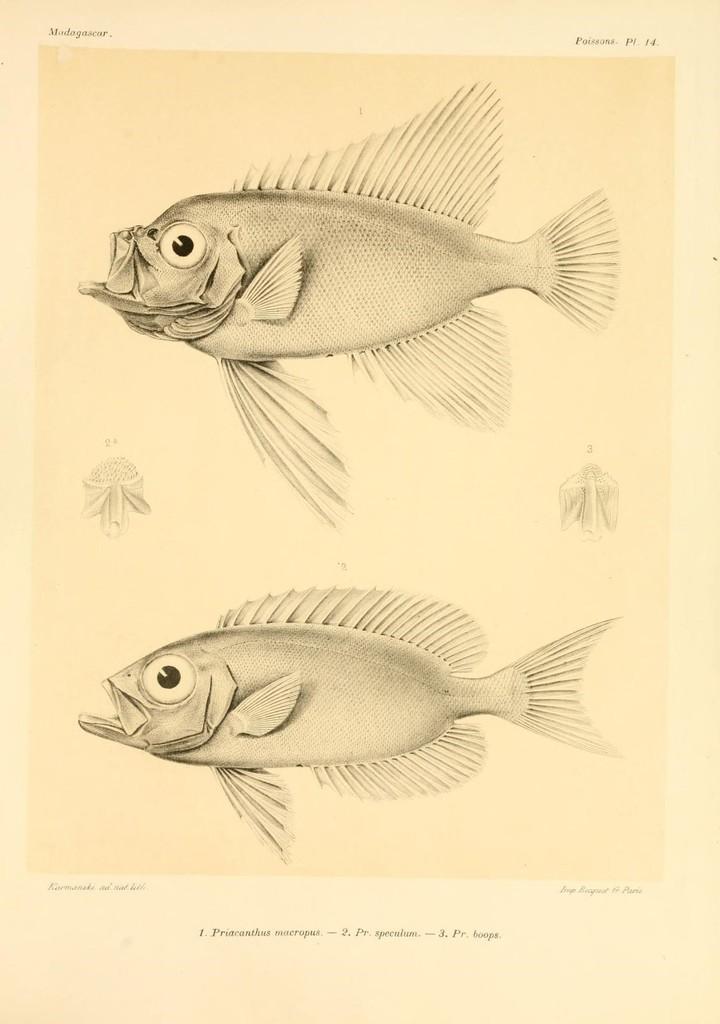Please provide a concise description of this image. It is a poster. In this image there are depictions of fish and there is some text on the image. 